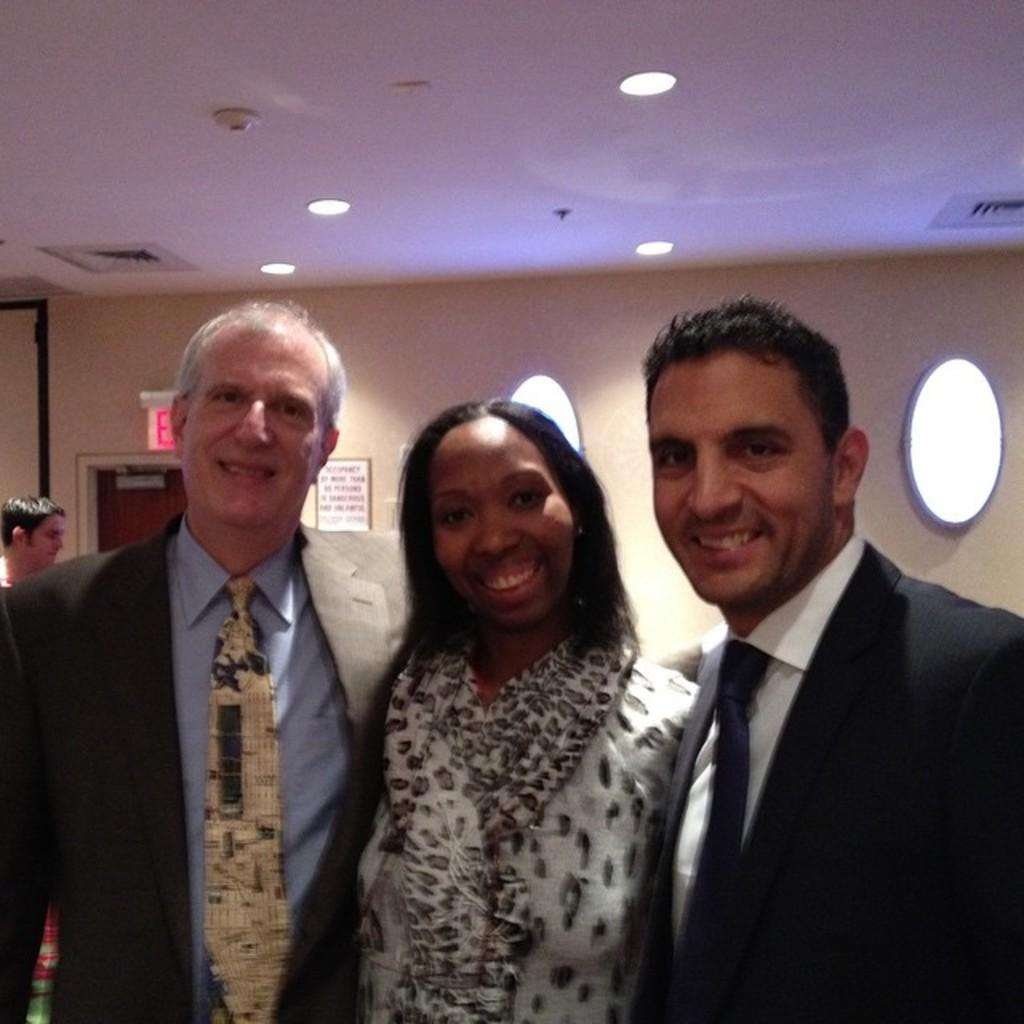What are the people in the image wearing? The persons in the image are wearing clothes. What can be seen on the ceiling in the image? There are lights on the ceiling in the image. Where is the ceiling located in the image? The ceiling is at the top of the image. What is visible in the background of the image? There is a wall in the background of the image. How many apples are hanging from the wall in the image? There are no apples present in the image; only lights on the ceiling, persons wearing clothes, and a wall in the background are visible. 